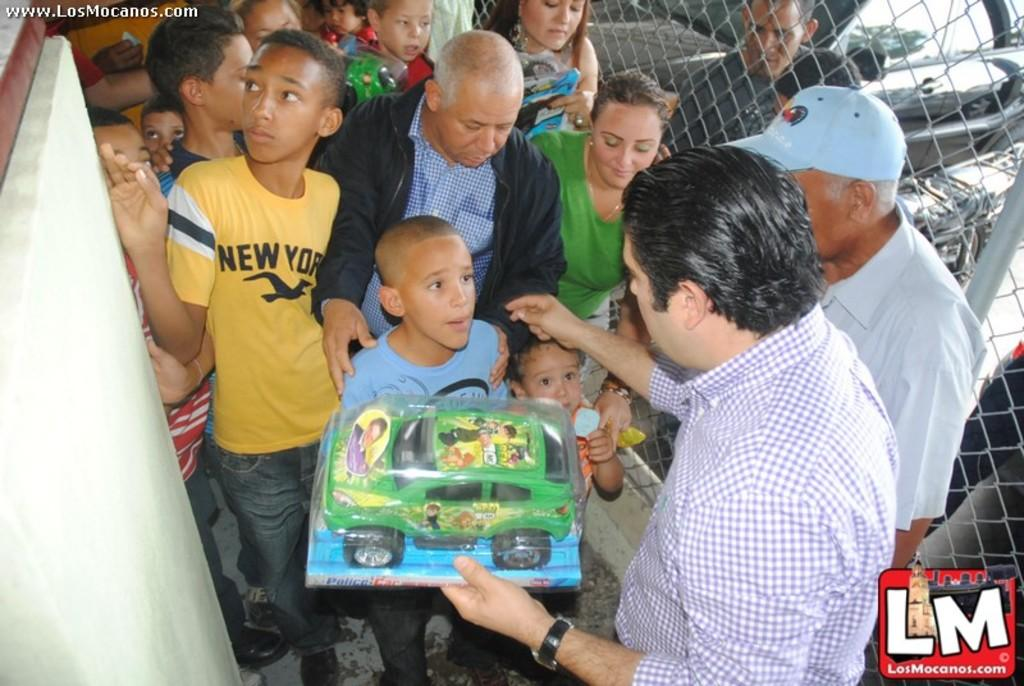Who are the people in the image? There are Amish people in the image. What are the people holding in the image? The people are holding toy cars. What else can be seen in the image besides the people? There are vehicles in the image. Are there any identifiable marks or logos in the image? Yes, there is a watermark in the left side corner of the image and a logo in the right side bottom of the image. What type of slip is the lawyer wearing in the image? There is no lawyer or slip present in the image; it features Amish people holding toy cars. How does the rubbing of the logo affect the image quality? There is no rubbing mentioned in the image, and the logo is present in the image without any indication of rubbing. 